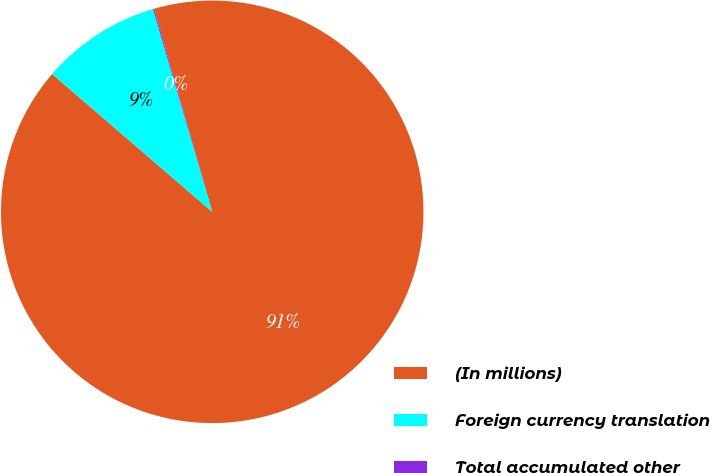Convert chart. <chart><loc_0><loc_0><loc_500><loc_500><pie_chart><fcel>(In millions)<fcel>Foreign currency translation<fcel>Total accumulated other<nl><fcel>90.75%<fcel>9.16%<fcel>0.09%<nl></chart> 